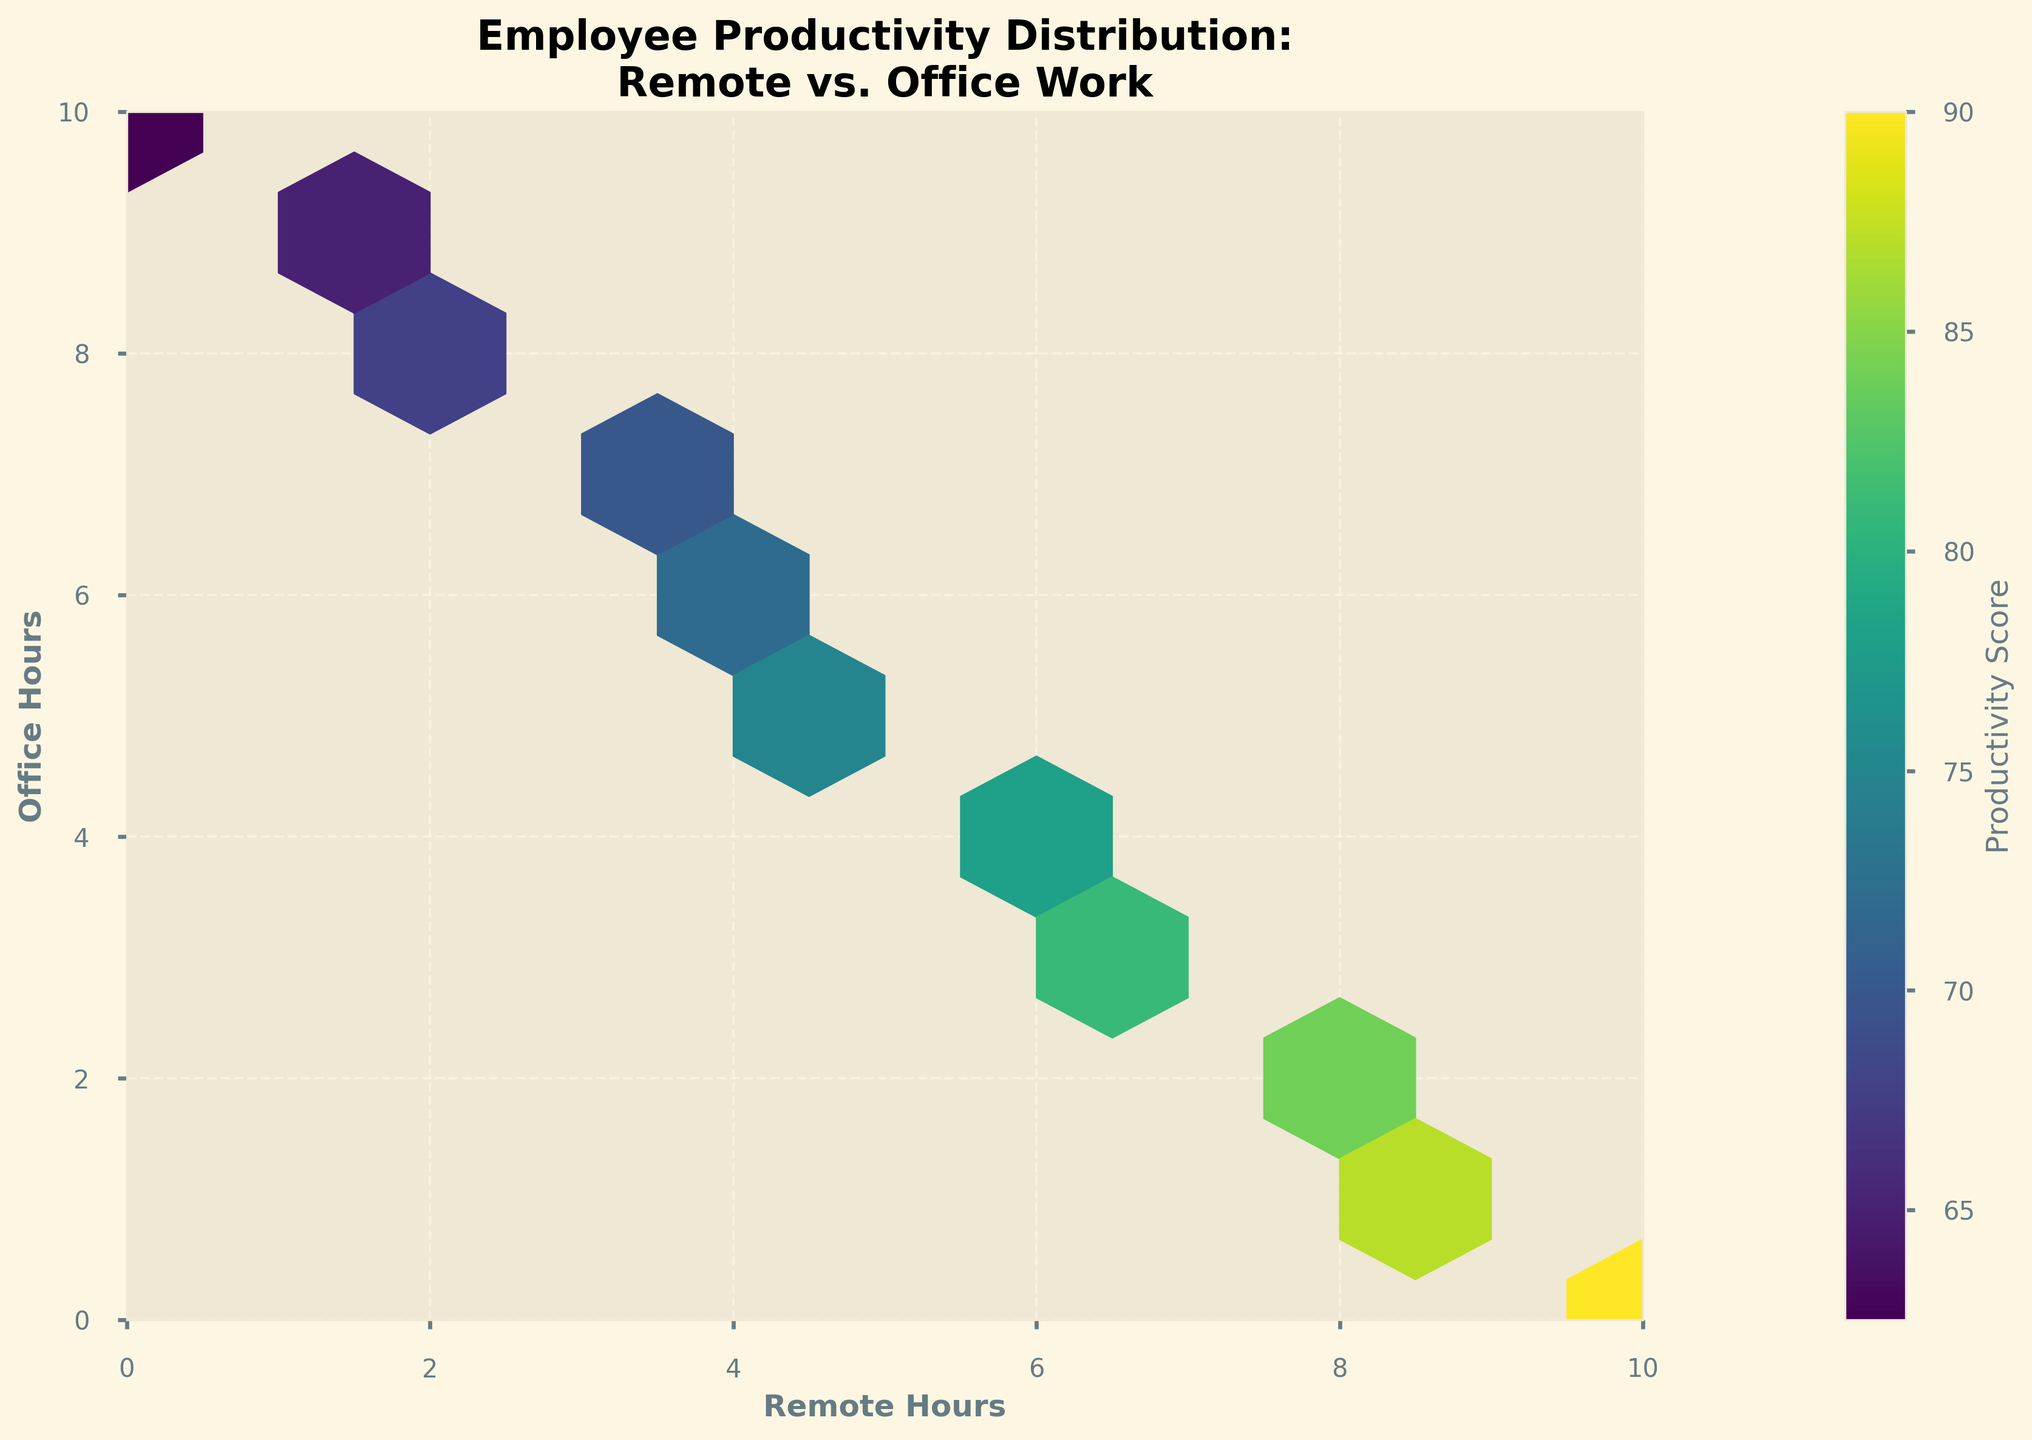What's the title of the hexbin plot? The title of the hexbin plot is typically one of the most prominent textual elements, usually displayed at the top. For this plot, it's "Employee Productivity Distribution: Remote vs. Office Work".
Answer: "Employee Productivity Distribution: Remote vs. Office Work" What is the color gradient used for the productivity scores in the plot? The color gradient is derived from the viridis colormap, which transitions from dark purple to bright yellow as productivity scores increase.
Answer: Viridis color gradient What is the range of Remote Hours shown on the x-axis? We look at the x-axis labels to determine the range of Remote Hours. This axis goes from 0 to 10.
Answer: 0 to 10 How many hexagons represent the highest productivity scores and what color do they appear? By examining the color bar, we can see that the highest productivity scores correspond to the brightest yellow colors. The highest scores (approaching 90) are primarily located in the hexagons near the (9,1) and (10,0) coordinates.
Answer: 2 hexagons, bright yellow Do the hexagons appear more concentrated towards the remote hours or office hours? By analyzing the density of hexagons, one can observe they are more concentrated in the higher remote hours (6-10) and lower office hours (0-4).
Answer: Higher remote hours Which region represents employees with nearly equal hours in remote and office work? The region where remote and office hours are almost equal is represented by the diagonal stretching from (0,0) to (10,10). Hexagons like (5,5) would be part of this region.
Answer: Around the (5,5) region Is it visually apparent which mode of work (remote or office) is associated with higher productivity scores? The highest productivity scores appear in areas with predominantly high remote hours (e.g., 9 remote hours and 1 office hour). Low productivity scores (below 70) are more frequent when office hours are larger.
Answer: Higher productivity with more remote hours What is the productivity score range indicated by the color bar? The color bar alongside the plot shows the range of productivity scores, with values ranging from the lowest (dark purple) to the highest (bright yellow).
Answer: 62 to 90 Which coordinate representing a mix of remote and office hours has the lowest productivity score? The lowest productivity score appears at (0 remote, 10 office) and (1 remote, 9 office), as indicated by the corresponding dark purple hexagons.
Answer: Coordinates (0,10) and (1,9) Are high or low productivity scores (color-coded) more frequent for employees who work mainly in the office? Most of the lower productivity scores (62-70, in dark purple to blue) belong to employees with higher office hours (e.g., 8-10), indicating lower productivity scores are more frequent for those who work mainly in the office.
Answer: Lower productivity scores 